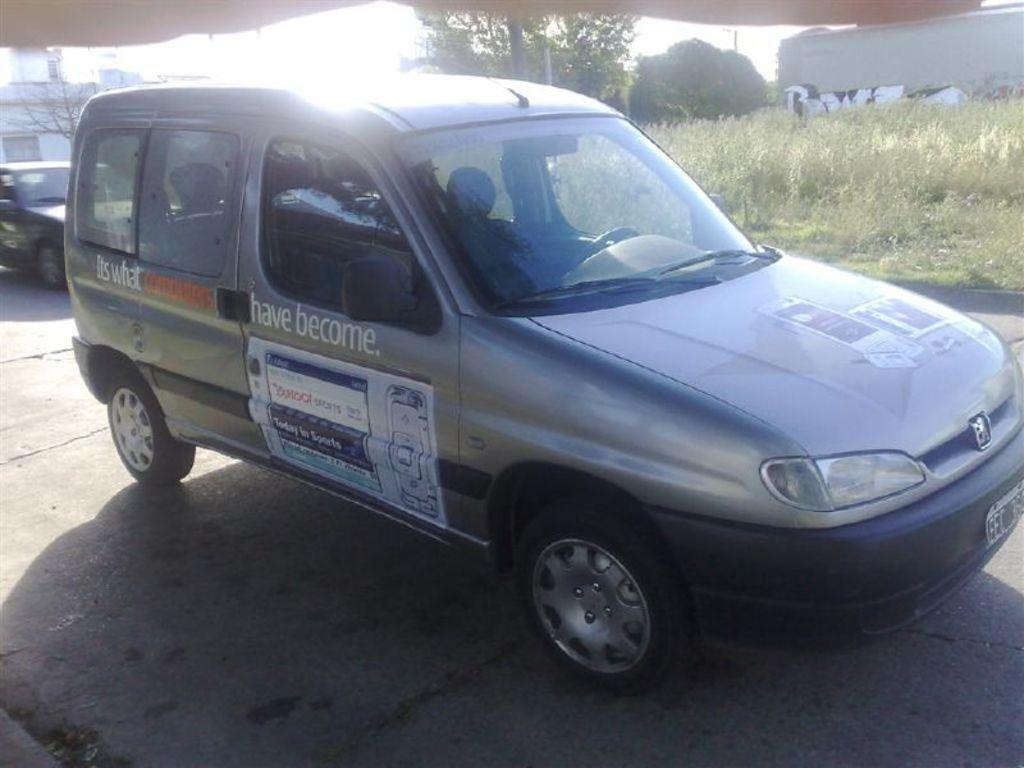<image>
Present a compact description of the photo's key features. A vehicle that says It's What Computers have Become down the side of it. 